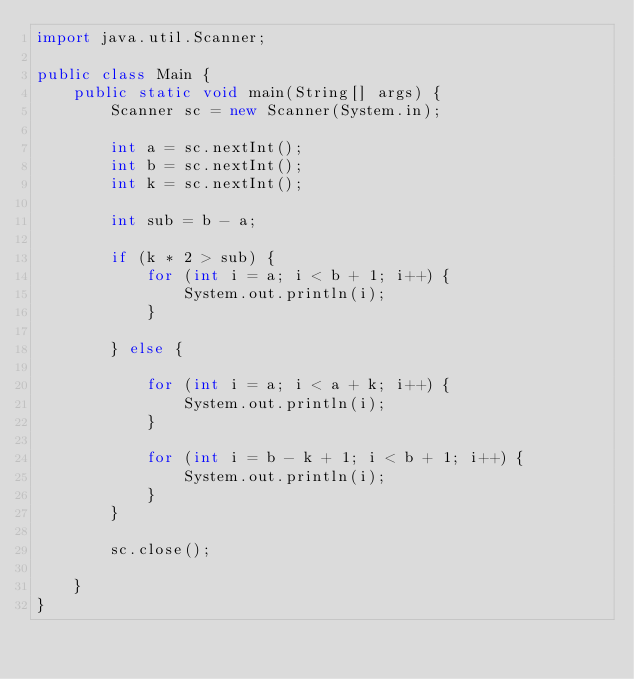<code> <loc_0><loc_0><loc_500><loc_500><_Java_>import java.util.Scanner;

public class Main {
	public static void main(String[] args) {
		Scanner sc = new Scanner(System.in);

		int a = sc.nextInt();
		int b = sc.nextInt();
		int k = sc.nextInt();

		int sub = b - a;

		if (k * 2 > sub) {
			for (int i = a; i < b + 1; i++) {
				System.out.println(i);
			}

		} else {

			for (int i = a; i < a + k; i++) {
				System.out.println(i);
			}

			for (int i = b - k + 1; i < b + 1; i++) {
				System.out.println(i);
			}
		}

		sc.close();

	}
}
</code> 